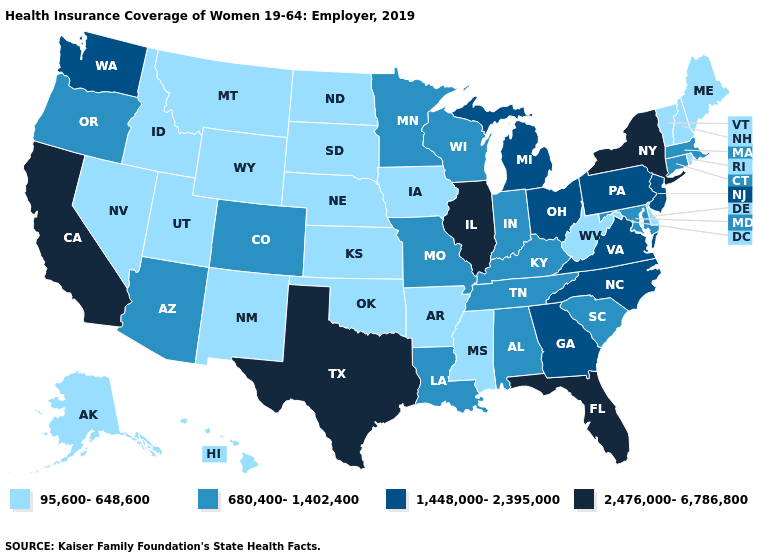Which states have the highest value in the USA?
Give a very brief answer. California, Florida, Illinois, New York, Texas. What is the highest value in states that border Utah?
Concise answer only. 680,400-1,402,400. Which states have the lowest value in the MidWest?
Answer briefly. Iowa, Kansas, Nebraska, North Dakota, South Dakota. What is the value of Virginia?
Write a very short answer. 1,448,000-2,395,000. What is the highest value in the West ?
Write a very short answer. 2,476,000-6,786,800. Does California have the highest value in the USA?
Keep it brief. Yes. Does Florida have the highest value in the South?
Short answer required. Yes. What is the value of West Virginia?
Concise answer only. 95,600-648,600. Name the states that have a value in the range 1,448,000-2,395,000?
Answer briefly. Georgia, Michigan, New Jersey, North Carolina, Ohio, Pennsylvania, Virginia, Washington. Which states have the lowest value in the USA?
Concise answer only. Alaska, Arkansas, Delaware, Hawaii, Idaho, Iowa, Kansas, Maine, Mississippi, Montana, Nebraska, Nevada, New Hampshire, New Mexico, North Dakota, Oklahoma, Rhode Island, South Dakota, Utah, Vermont, West Virginia, Wyoming. Which states hav the highest value in the South?
Concise answer only. Florida, Texas. Among the states that border Arkansas , does Mississippi have the lowest value?
Be succinct. Yes. What is the highest value in the MidWest ?
Answer briefly. 2,476,000-6,786,800. Does Montana have the highest value in the West?
Keep it brief. No. What is the lowest value in the South?
Concise answer only. 95,600-648,600. 